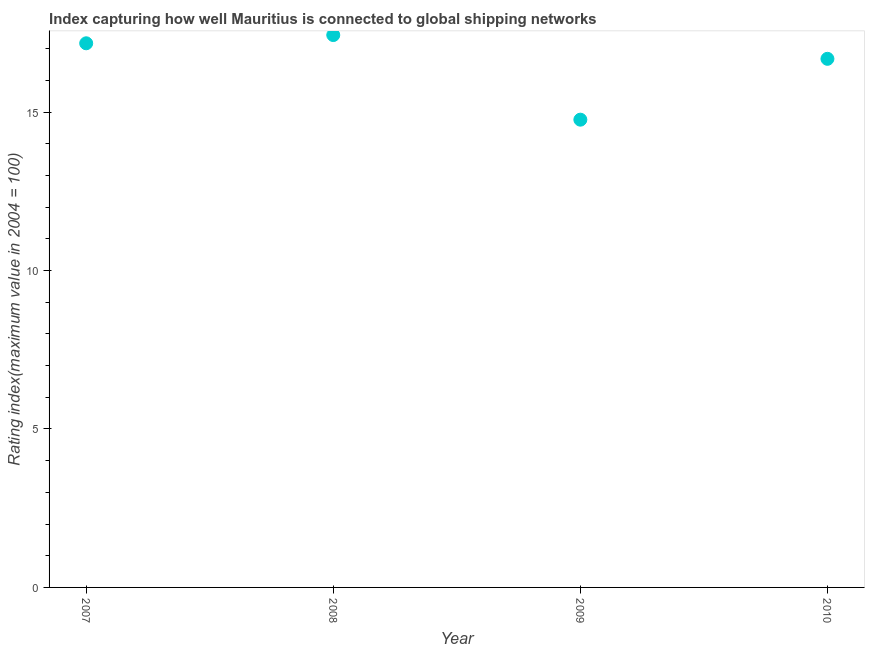What is the liner shipping connectivity index in 2007?
Provide a succinct answer. 17.17. Across all years, what is the maximum liner shipping connectivity index?
Offer a terse response. 17.43. Across all years, what is the minimum liner shipping connectivity index?
Make the answer very short. 14.76. What is the sum of the liner shipping connectivity index?
Provide a short and direct response. 66.04. What is the difference between the liner shipping connectivity index in 2009 and 2010?
Your response must be concise. -1.92. What is the average liner shipping connectivity index per year?
Ensure brevity in your answer.  16.51. What is the median liner shipping connectivity index?
Your response must be concise. 16.93. In how many years, is the liner shipping connectivity index greater than 5 ?
Your response must be concise. 4. Do a majority of the years between 2010 and 2007 (inclusive) have liner shipping connectivity index greater than 15 ?
Your response must be concise. Yes. What is the ratio of the liner shipping connectivity index in 2007 to that in 2008?
Offer a terse response. 0.99. Is the liner shipping connectivity index in 2007 less than that in 2010?
Your answer should be compact. No. What is the difference between the highest and the second highest liner shipping connectivity index?
Your answer should be very brief. 0.26. Is the sum of the liner shipping connectivity index in 2007 and 2009 greater than the maximum liner shipping connectivity index across all years?
Your response must be concise. Yes. What is the difference between the highest and the lowest liner shipping connectivity index?
Your answer should be compact. 2.67. Does the liner shipping connectivity index monotonically increase over the years?
Offer a very short reply. No. What is the difference between two consecutive major ticks on the Y-axis?
Provide a succinct answer. 5. Are the values on the major ticks of Y-axis written in scientific E-notation?
Make the answer very short. No. Does the graph contain grids?
Provide a succinct answer. No. What is the title of the graph?
Your response must be concise. Index capturing how well Mauritius is connected to global shipping networks. What is the label or title of the X-axis?
Offer a very short reply. Year. What is the label or title of the Y-axis?
Offer a very short reply. Rating index(maximum value in 2004 = 100). What is the Rating index(maximum value in 2004 = 100) in 2007?
Your answer should be very brief. 17.17. What is the Rating index(maximum value in 2004 = 100) in 2008?
Offer a very short reply. 17.43. What is the Rating index(maximum value in 2004 = 100) in 2009?
Make the answer very short. 14.76. What is the Rating index(maximum value in 2004 = 100) in 2010?
Ensure brevity in your answer.  16.68. What is the difference between the Rating index(maximum value in 2004 = 100) in 2007 and 2008?
Provide a short and direct response. -0.26. What is the difference between the Rating index(maximum value in 2004 = 100) in 2007 and 2009?
Offer a very short reply. 2.41. What is the difference between the Rating index(maximum value in 2004 = 100) in 2007 and 2010?
Give a very brief answer. 0.49. What is the difference between the Rating index(maximum value in 2004 = 100) in 2008 and 2009?
Keep it short and to the point. 2.67. What is the difference between the Rating index(maximum value in 2004 = 100) in 2008 and 2010?
Offer a very short reply. 0.75. What is the difference between the Rating index(maximum value in 2004 = 100) in 2009 and 2010?
Offer a terse response. -1.92. What is the ratio of the Rating index(maximum value in 2004 = 100) in 2007 to that in 2008?
Your answer should be very brief. 0.98. What is the ratio of the Rating index(maximum value in 2004 = 100) in 2007 to that in 2009?
Make the answer very short. 1.16. What is the ratio of the Rating index(maximum value in 2004 = 100) in 2007 to that in 2010?
Make the answer very short. 1.03. What is the ratio of the Rating index(maximum value in 2004 = 100) in 2008 to that in 2009?
Give a very brief answer. 1.18. What is the ratio of the Rating index(maximum value in 2004 = 100) in 2008 to that in 2010?
Provide a short and direct response. 1.04. What is the ratio of the Rating index(maximum value in 2004 = 100) in 2009 to that in 2010?
Keep it short and to the point. 0.89. 